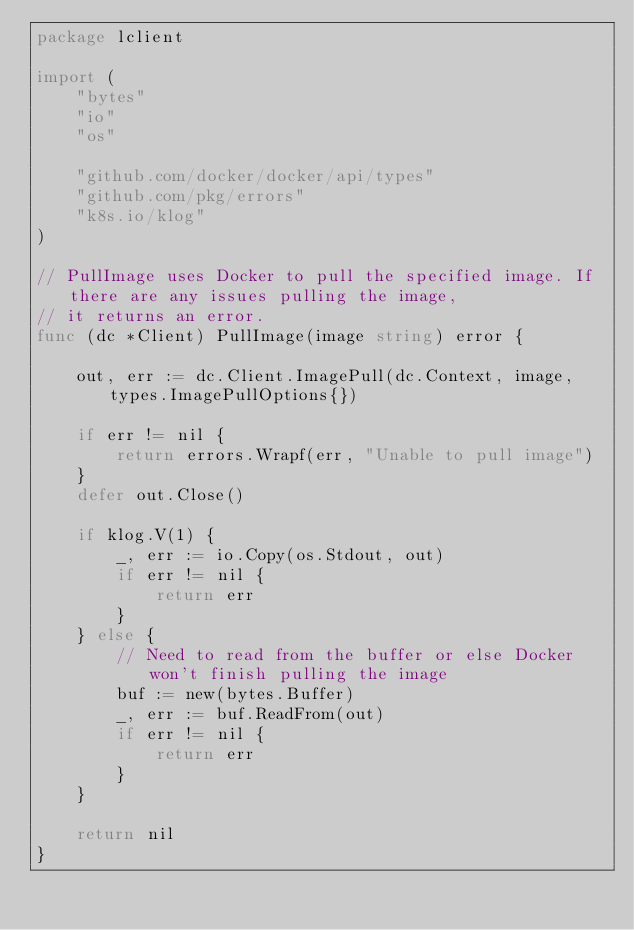<code> <loc_0><loc_0><loc_500><loc_500><_Go_>package lclient

import (
	"bytes"
	"io"
	"os"

	"github.com/docker/docker/api/types"
	"github.com/pkg/errors"
	"k8s.io/klog"
)

// PullImage uses Docker to pull the specified image. If there are any issues pulling the image,
// it returns an error.
func (dc *Client) PullImage(image string) error {

	out, err := dc.Client.ImagePull(dc.Context, image, types.ImagePullOptions{})

	if err != nil {
		return errors.Wrapf(err, "Unable to pull image")
	}
	defer out.Close()

	if klog.V(1) {
		_, err := io.Copy(os.Stdout, out)
		if err != nil {
			return err
		}
	} else {
		// Need to read from the buffer or else Docker won't finish pulling the image
		buf := new(bytes.Buffer)
		_, err := buf.ReadFrom(out)
		if err != nil {
			return err
		}
	}

	return nil
}
</code> 